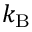Convert formula to latex. <formula><loc_0><loc_0><loc_500><loc_500>\, k _ { B }</formula> 